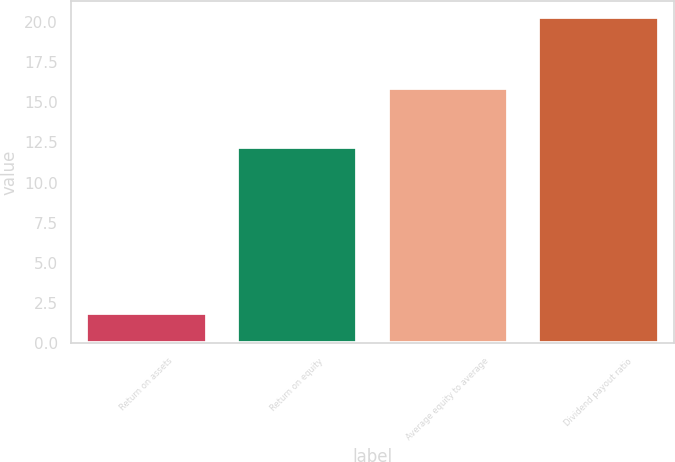<chart> <loc_0><loc_0><loc_500><loc_500><bar_chart><fcel>Return on assets<fcel>Return on equity<fcel>Average equity to average<fcel>Dividend payout ratio<nl><fcel>1.9<fcel>12.2<fcel>15.9<fcel>20.3<nl></chart> 